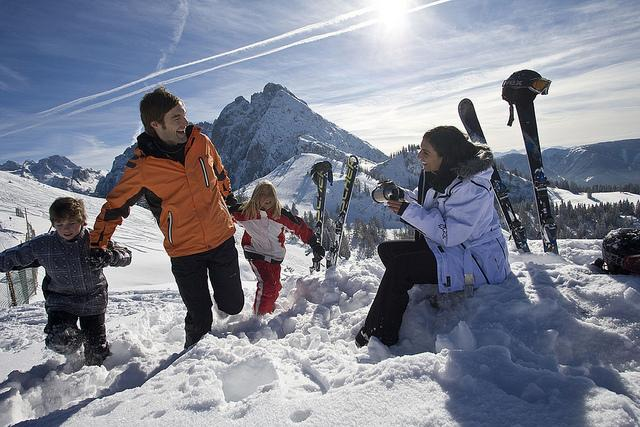What would be the most appropriate beverage for the family to have?

Choices:
A) milk
B) iced tea
C) cola
D) coffee coffee 